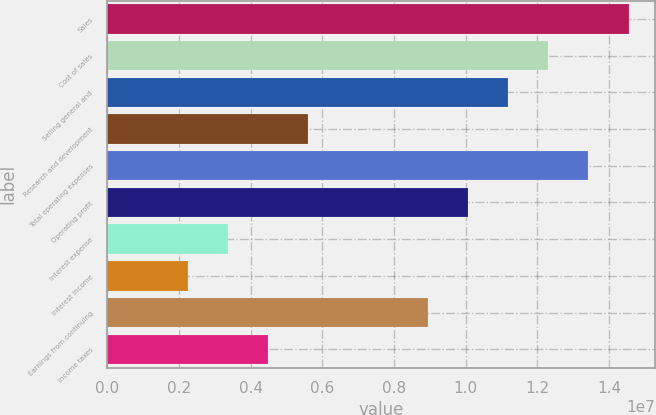<chart> <loc_0><loc_0><loc_500><loc_500><bar_chart><fcel>Sales<fcel>Cost of sales<fcel>Selling general and<fcel>Research and development<fcel>Total operating expenses<fcel>Operating profit<fcel>Interest expense<fcel>Interest income<fcel>Earnings from continuing<fcel>Income taxes<nl><fcel>1.45404e+07<fcel>1.23034e+07<fcel>1.11849e+07<fcel>5.59247e+06<fcel>1.34219e+07<fcel>1.00664e+07<fcel>3.35548e+06<fcel>2.23699e+06<fcel>8.94795e+06<fcel>4.47398e+06<nl></chart> 